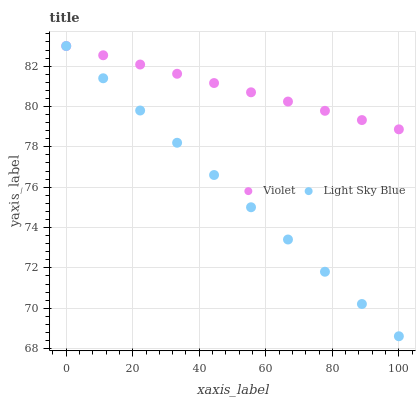Does Light Sky Blue have the minimum area under the curve?
Answer yes or no. Yes. Does Violet have the maximum area under the curve?
Answer yes or no. Yes. Does Violet have the minimum area under the curve?
Answer yes or no. No. Is Violet the smoothest?
Answer yes or no. Yes. Is Light Sky Blue the roughest?
Answer yes or no. Yes. Is Violet the roughest?
Answer yes or no. No. Does Light Sky Blue have the lowest value?
Answer yes or no. Yes. Does Violet have the lowest value?
Answer yes or no. No. Does Violet have the highest value?
Answer yes or no. Yes. Does Light Sky Blue intersect Violet?
Answer yes or no. Yes. Is Light Sky Blue less than Violet?
Answer yes or no. No. Is Light Sky Blue greater than Violet?
Answer yes or no. No. 